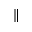<formula> <loc_0><loc_0><loc_500><loc_500>\|</formula> 